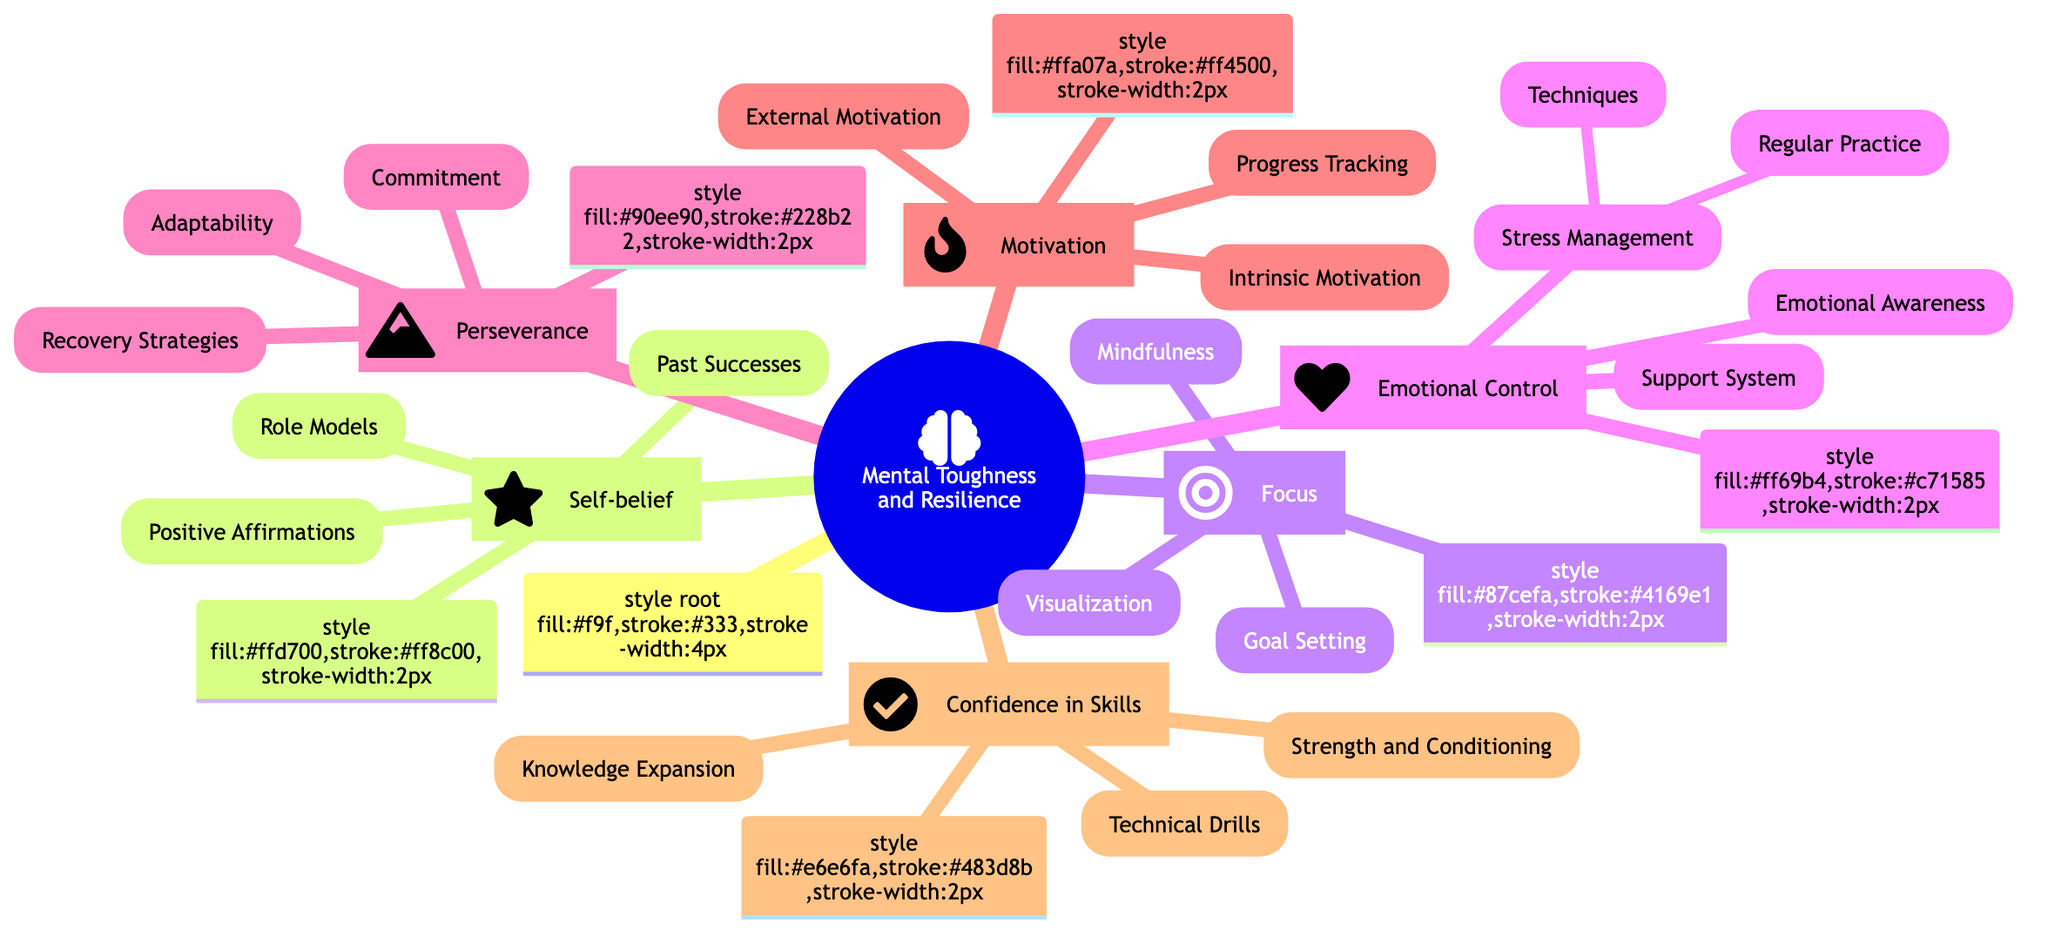What are the main categories under "Mental Toughness and Resilience"? The main categories represented in the mind map are Self-belief, Focus, Emotional Control, Perseverance, Motivation, and Confidence in Skills. Each category is a child node under the main node, indicating the primary components of mental toughness and resilience.
Answer: Self-belief, Focus, Emotional Control, Perseverance, Motivation, Confidence in Skills How many strategies are listed under "Focus"? The subcategories under "Focus" include Goal Setting, Mindfulness, and Visualization, which makes a total of three distinct strategies. By counting these child nodes, we get the correct number.
Answer: 3 What emotion-related strategy is mentioned under "Emotional Control"? The strategy mentioned under "Emotional Control" that relates to understanding emotions is Emotional Awareness, which is explicitly listed as a key component in the diagram.
Answer: Emotional Awareness Which node has the most subcategories? Among all categories, "Emotional Control" has the most subcategories, including Stress Management, Emotional Awareness, and Support System. The detailed examination shows Emotional Control has three categories, while others have fewer.
Answer: Emotional Control What technique is associated with Stress Management? The mind map lists Techniques and Regular Practice under Stress Management, hinting that both are methods to manage stress effectively. To be precise, the first specifically identified technique is Deep breathing, which can be inferred from the Techniques subcategory.
Answer: Techniques What is the primary focus of "Intrinsic Motivation"? The primary focus of Intrinsic Motivation is finding personal meaning and joy in swimming, as stated in the diagram, which encapsulates the essence of internal drive.
Answer: Finding personal meaning and joy in swimming How does "Recovery Strategies" relate to Perseverance? Recovery Strategies are listed as a subcategory under Perseverance, indicating that they are a method to maintain commitment and adaptability in the face of challenges. Their connection highlights the importance of rest and recuperation as vital aspects of persevering in sport.
Answer: They are a subcategory under Perseverance What kind of support is emphasized under Emotional Control? A Support System is emphasized under Emotional Control, as it is one of the methods to bolster emotional resilience by ensuring regular communication with coach, family, and friends. This highlights the community aspect of emotional control in sports.
Answer: Support System What activity is linked to mindfulness? The activity linked to mindfulness is practices like meditation or yoga, which are both mentioned as techniques to improve concentration and manage focus. This shows how mindfulness is relevant to enhancing mental clarity.
Answer: Meditation or yoga 